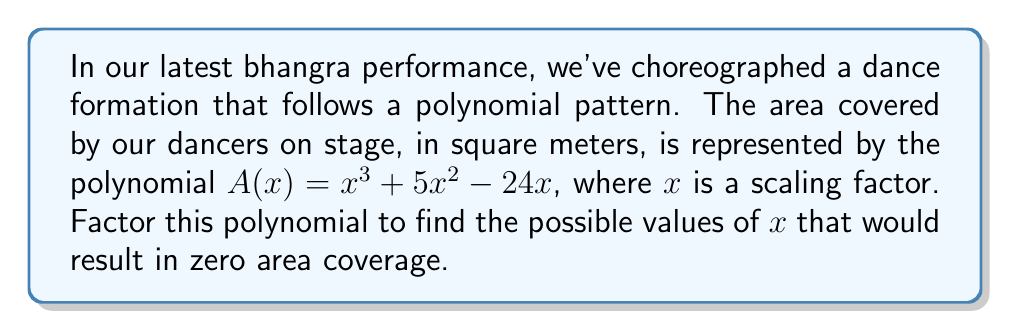Solve this math problem. Let's factor the polynomial $A(x) = x^3 + 5x^2 - 24x$ step by step:

1) First, we can factor out the greatest common factor:
   $A(x) = x(x^2 + 5x - 24)$

2) Now we need to factor the quadratic expression $x^2 + 5x - 24$:
   
   a) We're looking for two numbers that multiply to give -24 and add to give 5.
   b) These numbers are 8 and -3.

3) We can rewrite the quadratic as:
   $x^2 + 5x - 24 = x^2 + 8x - 3x - 24 = x(x + 8) - 3(x + 8) = (x - 3)(x + 8)$

4) Putting it all together:
   $A(x) = x(x^2 + 5x - 24) = x(x - 3)(x + 8)$

5) The roots of this polynomial (values of $x$ that make $A(x) = 0$) are:
   $x = 0$, $x = 3$, and $x = -8$

These values of $x$ represent the scaling factors that would result in zero area coverage in our dance formation.
Answer: $A(x) = x(x - 3)(x + 8)$ 